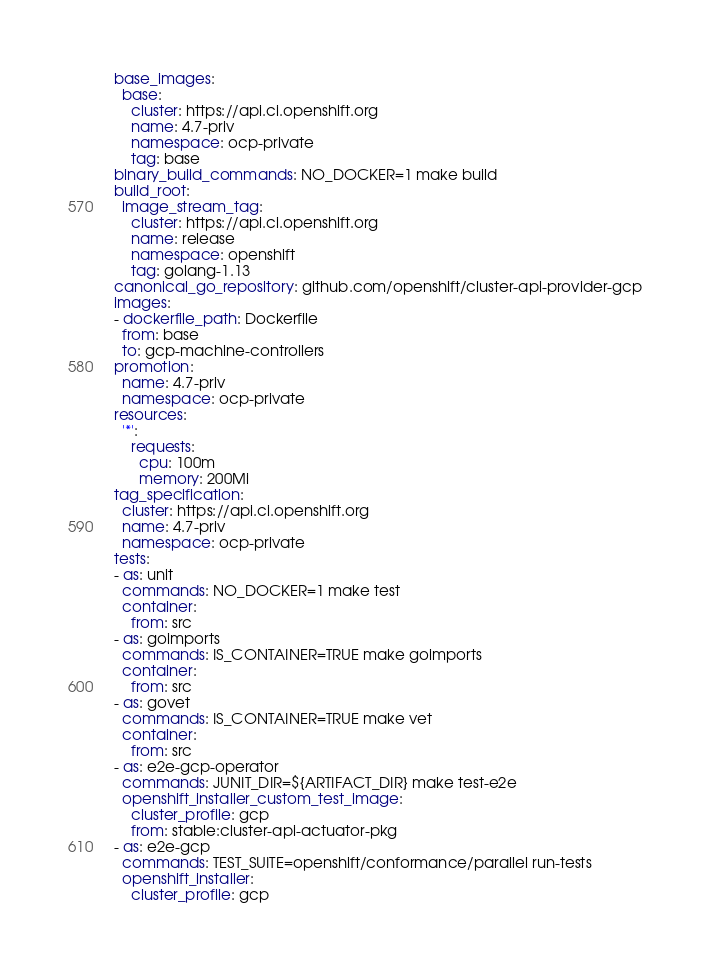Convert code to text. <code><loc_0><loc_0><loc_500><loc_500><_YAML_>base_images:
  base:
    cluster: https://api.ci.openshift.org
    name: 4.7-priv
    namespace: ocp-private
    tag: base
binary_build_commands: NO_DOCKER=1 make build
build_root:
  image_stream_tag:
    cluster: https://api.ci.openshift.org
    name: release
    namespace: openshift
    tag: golang-1.13
canonical_go_repository: github.com/openshift/cluster-api-provider-gcp
images:
- dockerfile_path: Dockerfile
  from: base
  to: gcp-machine-controllers
promotion:
  name: 4.7-priv
  namespace: ocp-private
resources:
  '*':
    requests:
      cpu: 100m
      memory: 200Mi
tag_specification:
  cluster: https://api.ci.openshift.org
  name: 4.7-priv
  namespace: ocp-private
tests:
- as: unit
  commands: NO_DOCKER=1 make test
  container:
    from: src
- as: goimports
  commands: IS_CONTAINER=TRUE make goimports
  container:
    from: src
- as: govet
  commands: IS_CONTAINER=TRUE make vet
  container:
    from: src
- as: e2e-gcp-operator
  commands: JUNIT_DIR=${ARTIFACT_DIR} make test-e2e
  openshift_installer_custom_test_image:
    cluster_profile: gcp
    from: stable:cluster-api-actuator-pkg
- as: e2e-gcp
  commands: TEST_SUITE=openshift/conformance/parallel run-tests
  openshift_installer:
    cluster_profile: gcp
</code> 